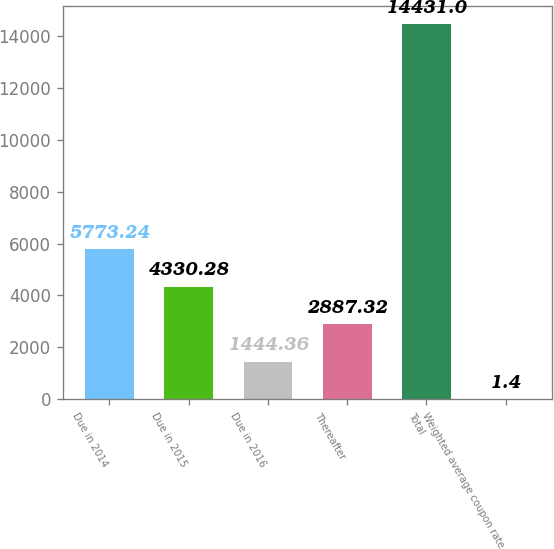Convert chart to OTSL. <chart><loc_0><loc_0><loc_500><loc_500><bar_chart><fcel>Due in 2014<fcel>Due in 2015<fcel>Due in 2016<fcel>Thereafter<fcel>Total<fcel>Weighted average coupon rate<nl><fcel>5773.24<fcel>4330.28<fcel>1444.36<fcel>2887.32<fcel>14431<fcel>1.4<nl></chart> 